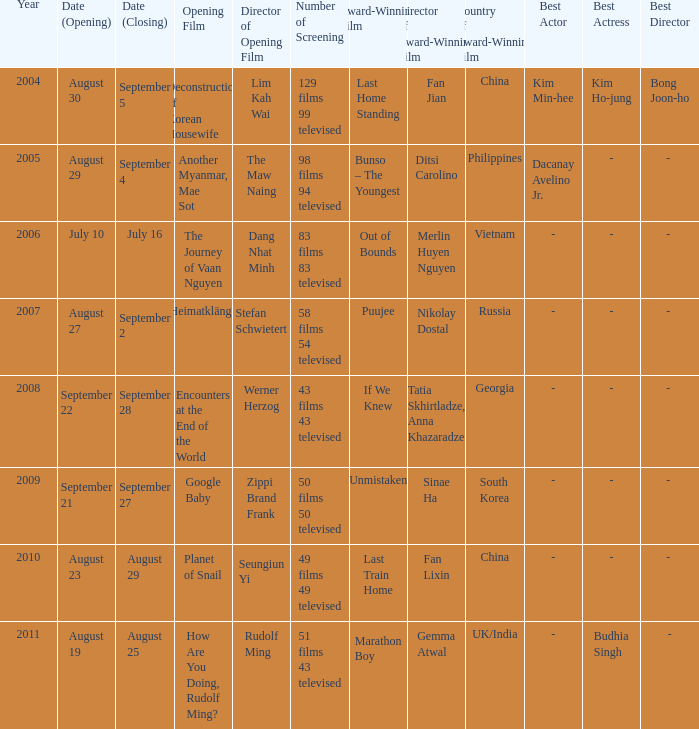Could you help me parse every detail presented in this table? {'header': ['Year', 'Date (Opening)', 'Date (Closing)', 'Opening Film', 'Director of Opening Film', 'Number of Screening', 'Award-Winning Film', 'Director of Award-Winning Film', 'Country of Award-Winning Film', 'Best Actor', 'Best Actress', 'Best Director'], 'rows': [['2004', 'August 30', 'September 5', 'Deconstruction of Korean Housewife', 'Lim Kah Wai', '129 films 99 televised', 'Last Home Standing', 'Fan Jian', 'China', 'Kim Min-hee', 'Kim Ho-jung', 'Bong Joon-ho'], ['2005', 'August 29', 'September 4', 'Another Myanmar, Mae Sot', 'The Maw Naing', '98 films 94 televised', 'Bunso – The Youngest', 'Ditsi Carolino', 'Philippines', 'Dacanay Avelino Jr.', '-', '- '], ['2006', 'July 10', 'July 16', 'The Journey of Vaan Nguyen', 'Dang Nhat Minh', '83 films 83 televised', 'Out of Bounds', 'Merlin Huyen Nguyen', 'Vietnam', '-', '-', '- '], ['2007', 'August 27', 'September 2', 'Heimatklänge', 'Stefan Schwietert', '58 films 54 televised', 'Puujee', 'Nikolay Dostal', 'Russia', '-', '-', '- '], ['2008', 'September 22', 'September 28', 'Encounters at the End of the World', 'Werner Herzog', '43 films 43 televised', 'If We Knew', 'Tatia Skhirtladze, Anna Khazaradze', 'Georgia', '-', '-', '- '], ['2009', 'September 21', 'September 27', 'Google Baby', 'Zippi Brand Frank', '50 films 50 televised', 'Unmistaken', 'Sinae Ha', 'South Korea', '-', '-', '- '], ['2010', 'August 23', 'August 29', 'Planet of Snail', 'Seungiun Yi', '49 films 49 televised', 'Last Train Home', 'Fan Lixin', 'China', '-', '-', '- '], ['2011', 'August 19', 'August 25', 'How Are You Doing, Rudolf Ming?', 'Rudolf Ming', '51 films 43 televised', 'Marathon Boy', 'Gemma Atwal', 'UK/India', '-', 'Budhia Singh', '-']]} How many screenings does the opening film of the journey of vaan nguyen have? 1.0. 